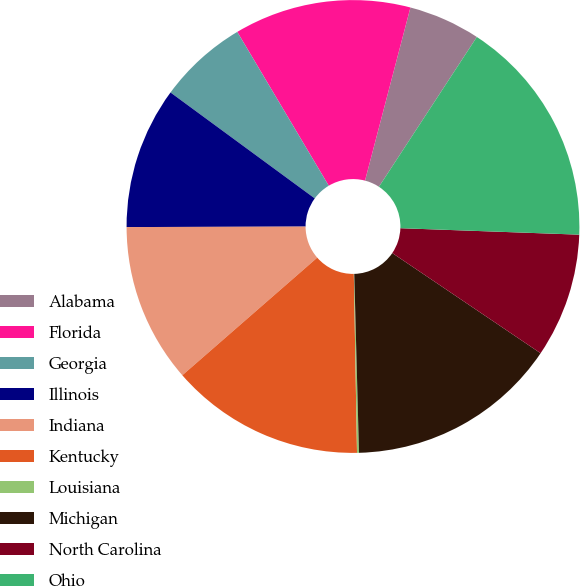Convert chart. <chart><loc_0><loc_0><loc_500><loc_500><pie_chart><fcel>Alabama<fcel>Florida<fcel>Georgia<fcel>Illinois<fcel>Indiana<fcel>Kentucky<fcel>Louisiana<fcel>Michigan<fcel>North Carolina<fcel>Ohio<nl><fcel>5.13%<fcel>12.62%<fcel>6.38%<fcel>10.12%<fcel>11.37%<fcel>13.87%<fcel>0.14%<fcel>15.12%<fcel>8.88%<fcel>16.36%<nl></chart> 